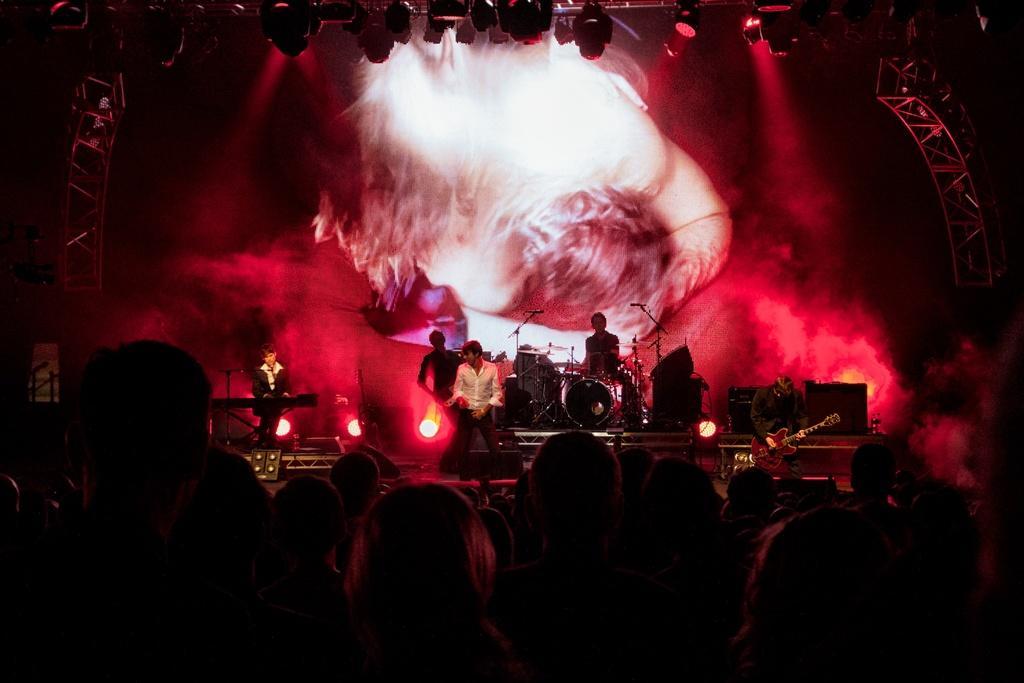Describe this image in one or two sentences. This picture describes about group of people, in the background of the image we can see few people, they are musicians, in the left side of the given image we can see a man is playing keyboard, and another person is playing drums, and also we can see few lights and metal rods. 